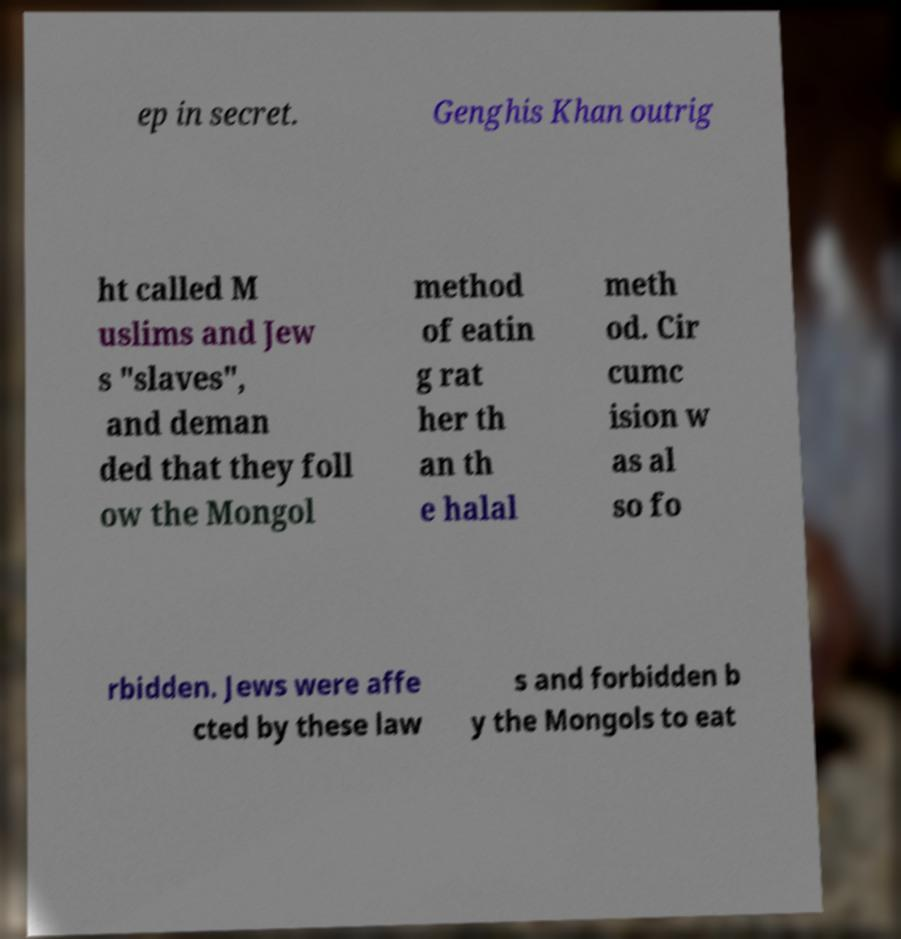Can you accurately transcribe the text from the provided image for me? ep in secret. Genghis Khan outrig ht called M uslims and Jew s "slaves", and deman ded that they foll ow the Mongol method of eatin g rat her th an th e halal meth od. Cir cumc ision w as al so fo rbidden. Jews were affe cted by these law s and forbidden b y the Mongols to eat 